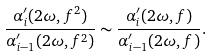Convert formula to latex. <formula><loc_0><loc_0><loc_500><loc_500>\frac { \alpha _ { i } ^ { \prime } ( 2 \omega , f ^ { 2 } ) } { \alpha _ { i - 1 } ^ { \prime } ( 2 \omega , f ^ { 2 } ) } \sim \frac { \alpha _ { i } ^ { \prime } ( 2 \omega , f ) } { \alpha _ { i - 1 } ^ { \prime } ( 2 \omega , f ) } .</formula> 